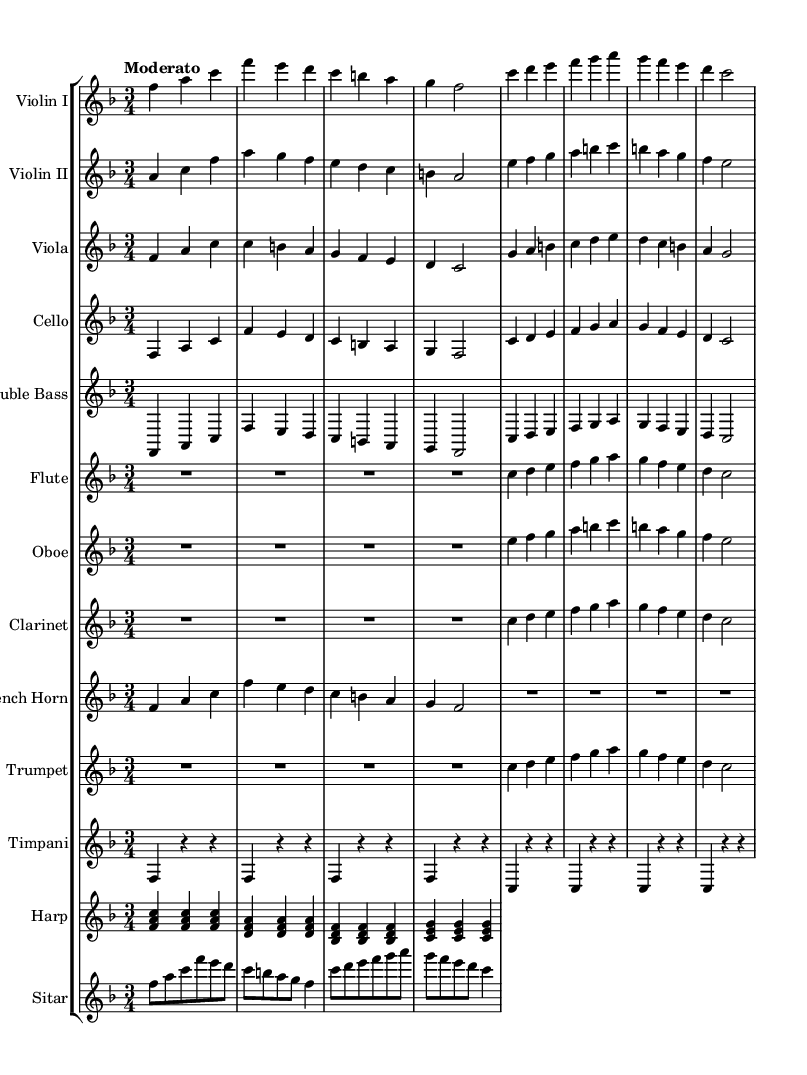what is the key signature of this music? The key signature is F major, which has one flat (B flat). This is indicated at the beginning of the staff with the flat symbol.
Answer: F major what is the time signature of this music? The time signature is 3/4, which is shown at the beginning of the sheet music. This indicates there are three beats per measure and a quarter note receives one beat.
Answer: 3/4 what is the tempo marking for this music? The tempo marking is "Moderato," which indicates a moderate speed for the piece. This marking is typically placed above the staff at the beginning of the music.
Answer: Moderato how many measures are present in the violin I part? The violin I part has a total of eight measures, as observed by counting the groupings of notes and the vertical bar lines that separate the measures.
Answer: 8 which instruments have a part written for them in this score? The score includes parts for Violin I, Violin II, Viola, Cello, Double Bass, Flute, Oboe, Clarinet, French Horn, Trumpet, Timpani, Harp, and Sitar. This can be seen at the beginning of each staff labeled with the respective instrument names.
Answer: Violin I, Violin II, Viola, Cello, Double Bass, Flute, Oboe, Clarinet, French Horn, Trumpet, Timpani, Harp, Sitar which instrument plays the lowest notes throughout the score? The Double Bass plays the lowest notes in this score, as it is generally the lowest sounding instrument in the orchestral arrangement, confirmed through the notation of lower pitch notes.
Answer: Double Bass how does the flute part begin in terms of note values? The flute part begins with a rest (R) for two beats, followed by four eighth notes (c, d, e, f), indicating the rhythm and start of the melody. This can be determined by examining the first few measures of the flute part.
Answer: R2.*4 